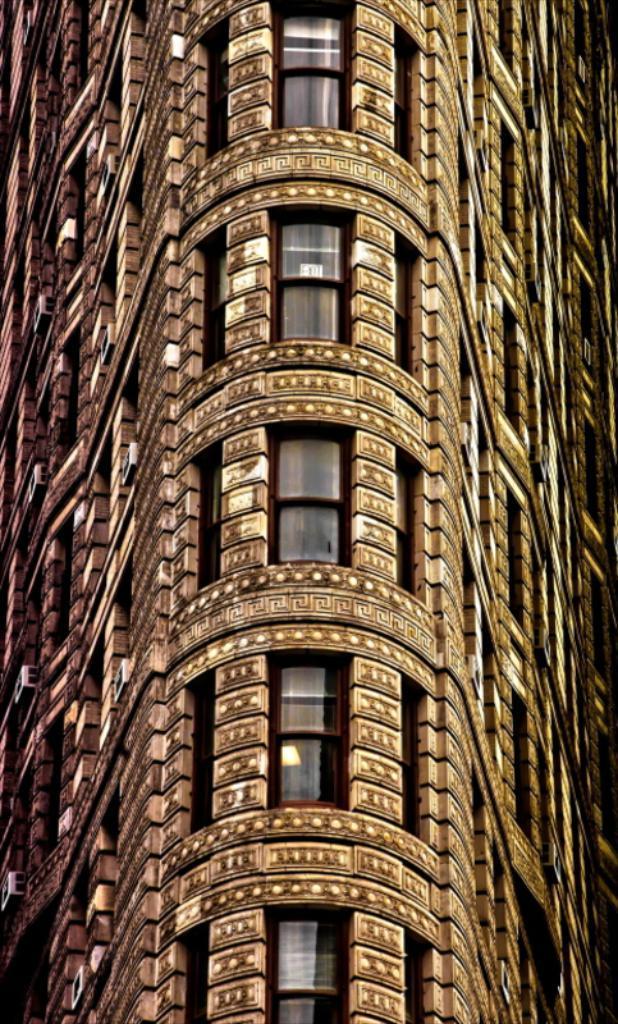Could you give a brief overview of what you see in this image? In this image we can see a building which is of brown color. 